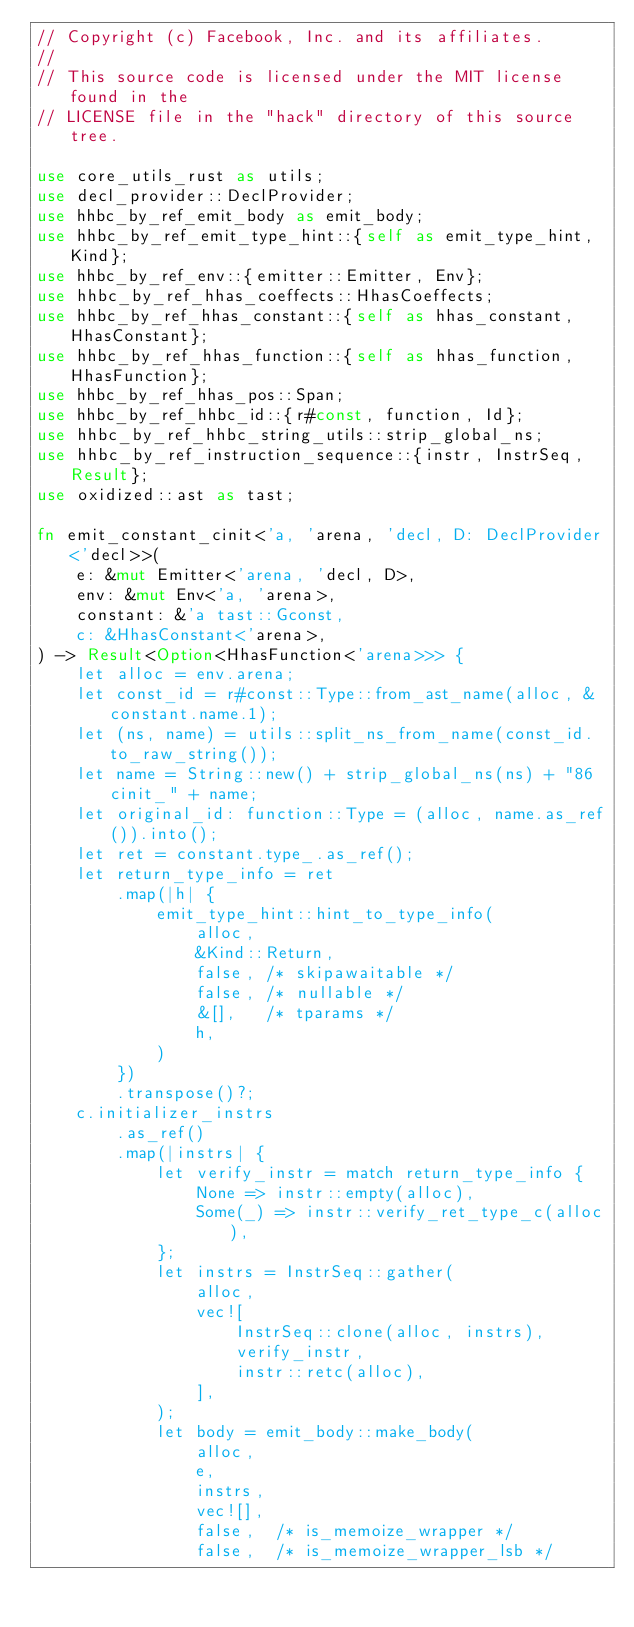Convert code to text. <code><loc_0><loc_0><loc_500><loc_500><_Rust_>// Copyright (c) Facebook, Inc. and its affiliates.
//
// This source code is licensed under the MIT license found in the
// LICENSE file in the "hack" directory of this source tree.

use core_utils_rust as utils;
use decl_provider::DeclProvider;
use hhbc_by_ref_emit_body as emit_body;
use hhbc_by_ref_emit_type_hint::{self as emit_type_hint, Kind};
use hhbc_by_ref_env::{emitter::Emitter, Env};
use hhbc_by_ref_hhas_coeffects::HhasCoeffects;
use hhbc_by_ref_hhas_constant::{self as hhas_constant, HhasConstant};
use hhbc_by_ref_hhas_function::{self as hhas_function, HhasFunction};
use hhbc_by_ref_hhas_pos::Span;
use hhbc_by_ref_hhbc_id::{r#const, function, Id};
use hhbc_by_ref_hhbc_string_utils::strip_global_ns;
use hhbc_by_ref_instruction_sequence::{instr, InstrSeq, Result};
use oxidized::ast as tast;

fn emit_constant_cinit<'a, 'arena, 'decl, D: DeclProvider<'decl>>(
    e: &mut Emitter<'arena, 'decl, D>,
    env: &mut Env<'a, 'arena>,
    constant: &'a tast::Gconst,
    c: &HhasConstant<'arena>,
) -> Result<Option<HhasFunction<'arena>>> {
    let alloc = env.arena;
    let const_id = r#const::Type::from_ast_name(alloc, &constant.name.1);
    let (ns, name) = utils::split_ns_from_name(const_id.to_raw_string());
    let name = String::new() + strip_global_ns(ns) + "86cinit_" + name;
    let original_id: function::Type = (alloc, name.as_ref()).into();
    let ret = constant.type_.as_ref();
    let return_type_info = ret
        .map(|h| {
            emit_type_hint::hint_to_type_info(
                alloc,
                &Kind::Return,
                false, /* skipawaitable */
                false, /* nullable */
                &[],   /* tparams */
                h,
            )
        })
        .transpose()?;
    c.initializer_instrs
        .as_ref()
        .map(|instrs| {
            let verify_instr = match return_type_info {
                None => instr::empty(alloc),
                Some(_) => instr::verify_ret_type_c(alloc),
            };
            let instrs = InstrSeq::gather(
                alloc,
                vec![
                    InstrSeq::clone(alloc, instrs),
                    verify_instr,
                    instr::retc(alloc),
                ],
            );
            let body = emit_body::make_body(
                alloc,
                e,
                instrs,
                vec![],
                false,  /* is_memoize_wrapper */
                false,  /* is_memoize_wrapper_lsb */</code> 